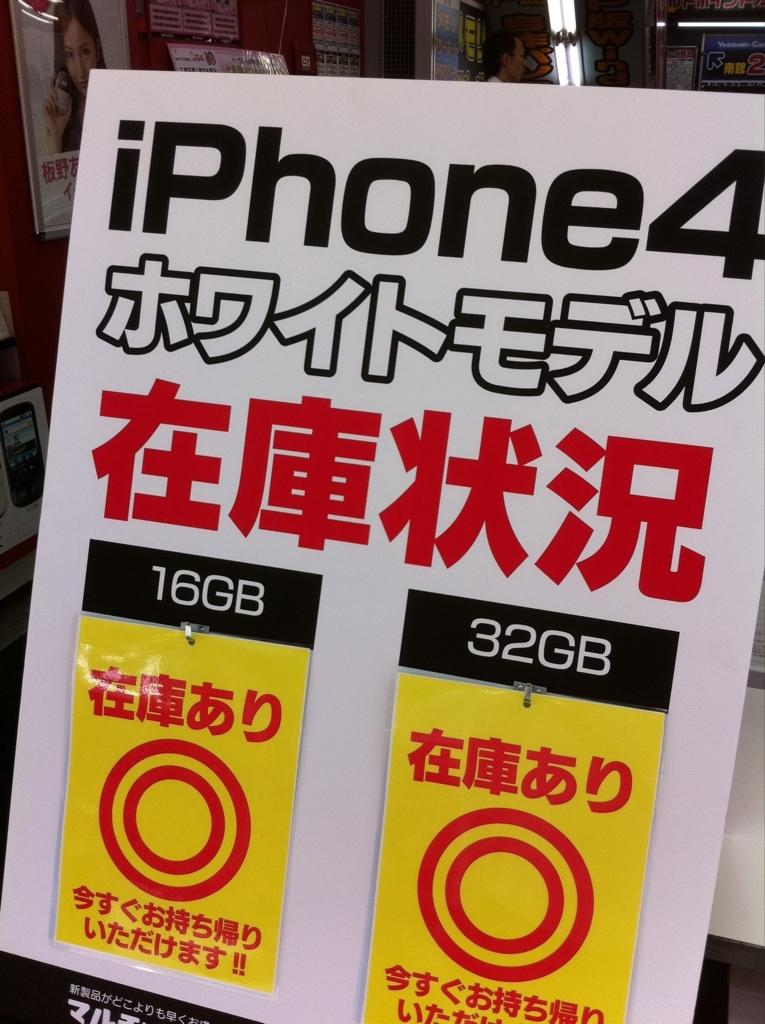What is present in the image related to written communication? There is a paper in the image. What can be found on the paper? The paper has texts on it. What is the color of the texts on the paper? The texts are in black color. How does the friction between the paper and the surface affect the movement of the feet in the image? There are no feet or movement present in the image; it only features a paper with black texts on it. 